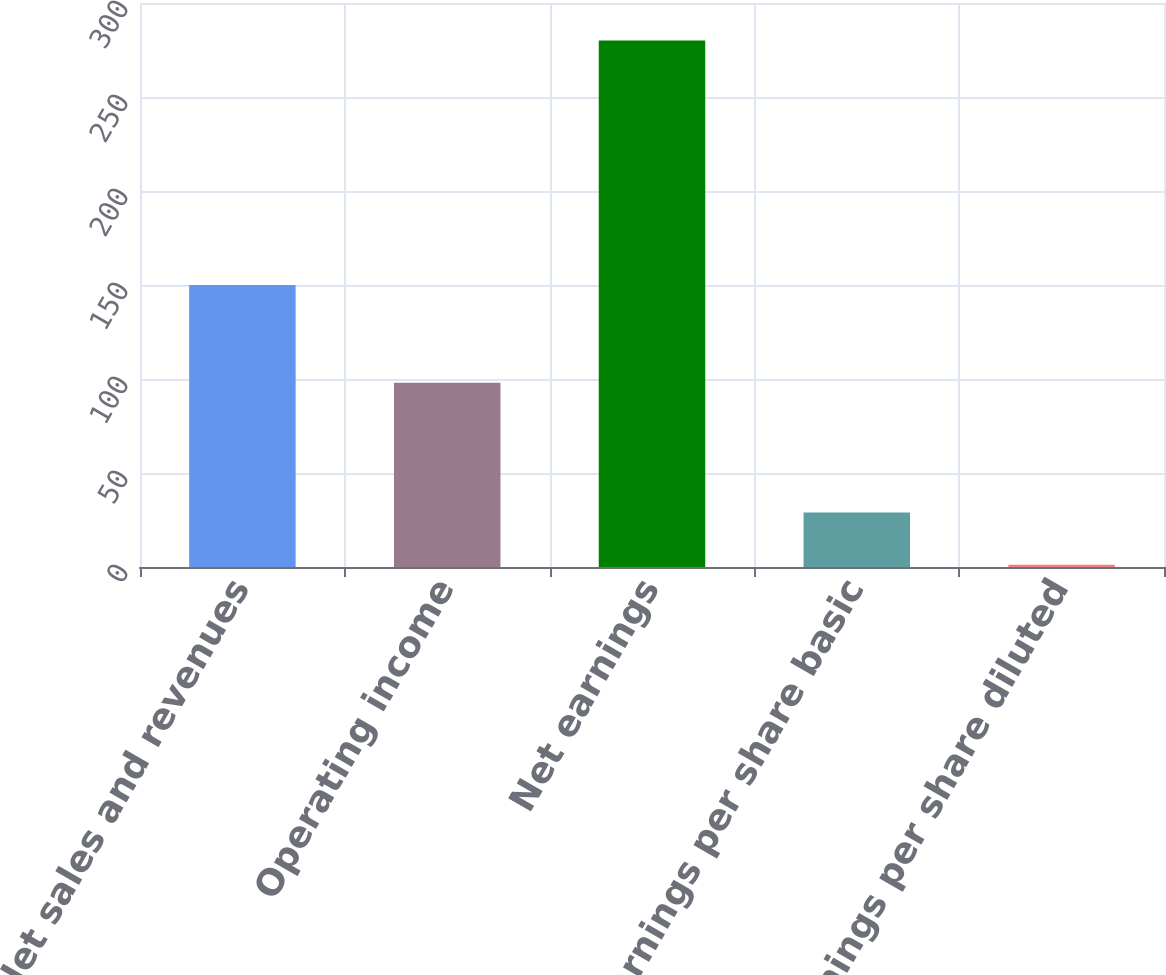<chart> <loc_0><loc_0><loc_500><loc_500><bar_chart><fcel>Net sales and revenues<fcel>Operating income<fcel>Net earnings<fcel>Net earnings per share basic<fcel>Net earnings per share diluted<nl><fcel>150<fcel>98<fcel>280<fcel>29.03<fcel>1.14<nl></chart> 